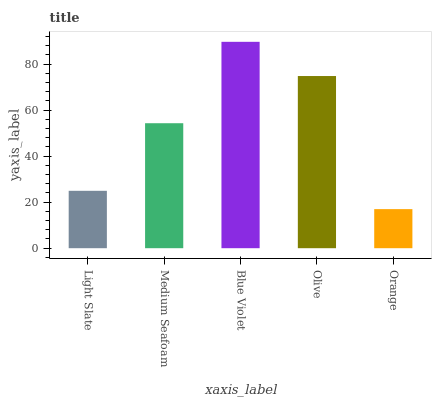Is Orange the minimum?
Answer yes or no. Yes. Is Blue Violet the maximum?
Answer yes or no. Yes. Is Medium Seafoam the minimum?
Answer yes or no. No. Is Medium Seafoam the maximum?
Answer yes or no. No. Is Medium Seafoam greater than Light Slate?
Answer yes or no. Yes. Is Light Slate less than Medium Seafoam?
Answer yes or no. Yes. Is Light Slate greater than Medium Seafoam?
Answer yes or no. No. Is Medium Seafoam less than Light Slate?
Answer yes or no. No. Is Medium Seafoam the high median?
Answer yes or no. Yes. Is Medium Seafoam the low median?
Answer yes or no. Yes. Is Olive the high median?
Answer yes or no. No. Is Olive the low median?
Answer yes or no. No. 